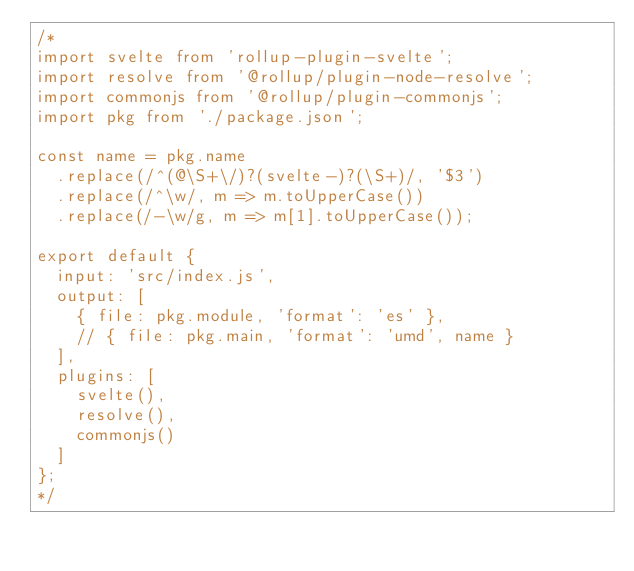<code> <loc_0><loc_0><loc_500><loc_500><_JavaScript_>/*
import svelte from 'rollup-plugin-svelte';
import resolve from '@rollup/plugin-node-resolve';
import commonjs from '@rollup/plugin-commonjs';
import pkg from './package.json';

const name = pkg.name
	.replace(/^(@\S+\/)?(svelte-)?(\S+)/, '$3')
	.replace(/^\w/, m => m.toUpperCase())
	.replace(/-\w/g, m => m[1].toUpperCase());

export default {
	input: 'src/index.js',
	output: [
		{ file: pkg.module, 'format': 'es' },
		// { file: pkg.main, 'format': 'umd', name }
	],
	plugins: [
		svelte(),
		resolve(),
		commonjs()
	]
};
*/
</code> 